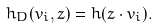<formula> <loc_0><loc_0><loc_500><loc_500>h _ { D } ( v _ { i } , z ) = h ( z \cdot v _ { i } ) .</formula> 